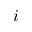<formula> <loc_0><loc_0><loc_500><loc_500>i</formula> 